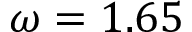Convert formula to latex. <formula><loc_0><loc_0><loc_500><loc_500>\omega = 1 . 6 5</formula> 